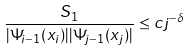Convert formula to latex. <formula><loc_0><loc_0><loc_500><loc_500>\frac { S _ { 1 } } { | \Psi _ { i - 1 } ( x _ { i } ) | | \Psi _ { j - 1 } ( x _ { j } ) | } \leq c j ^ { - \delta }</formula> 